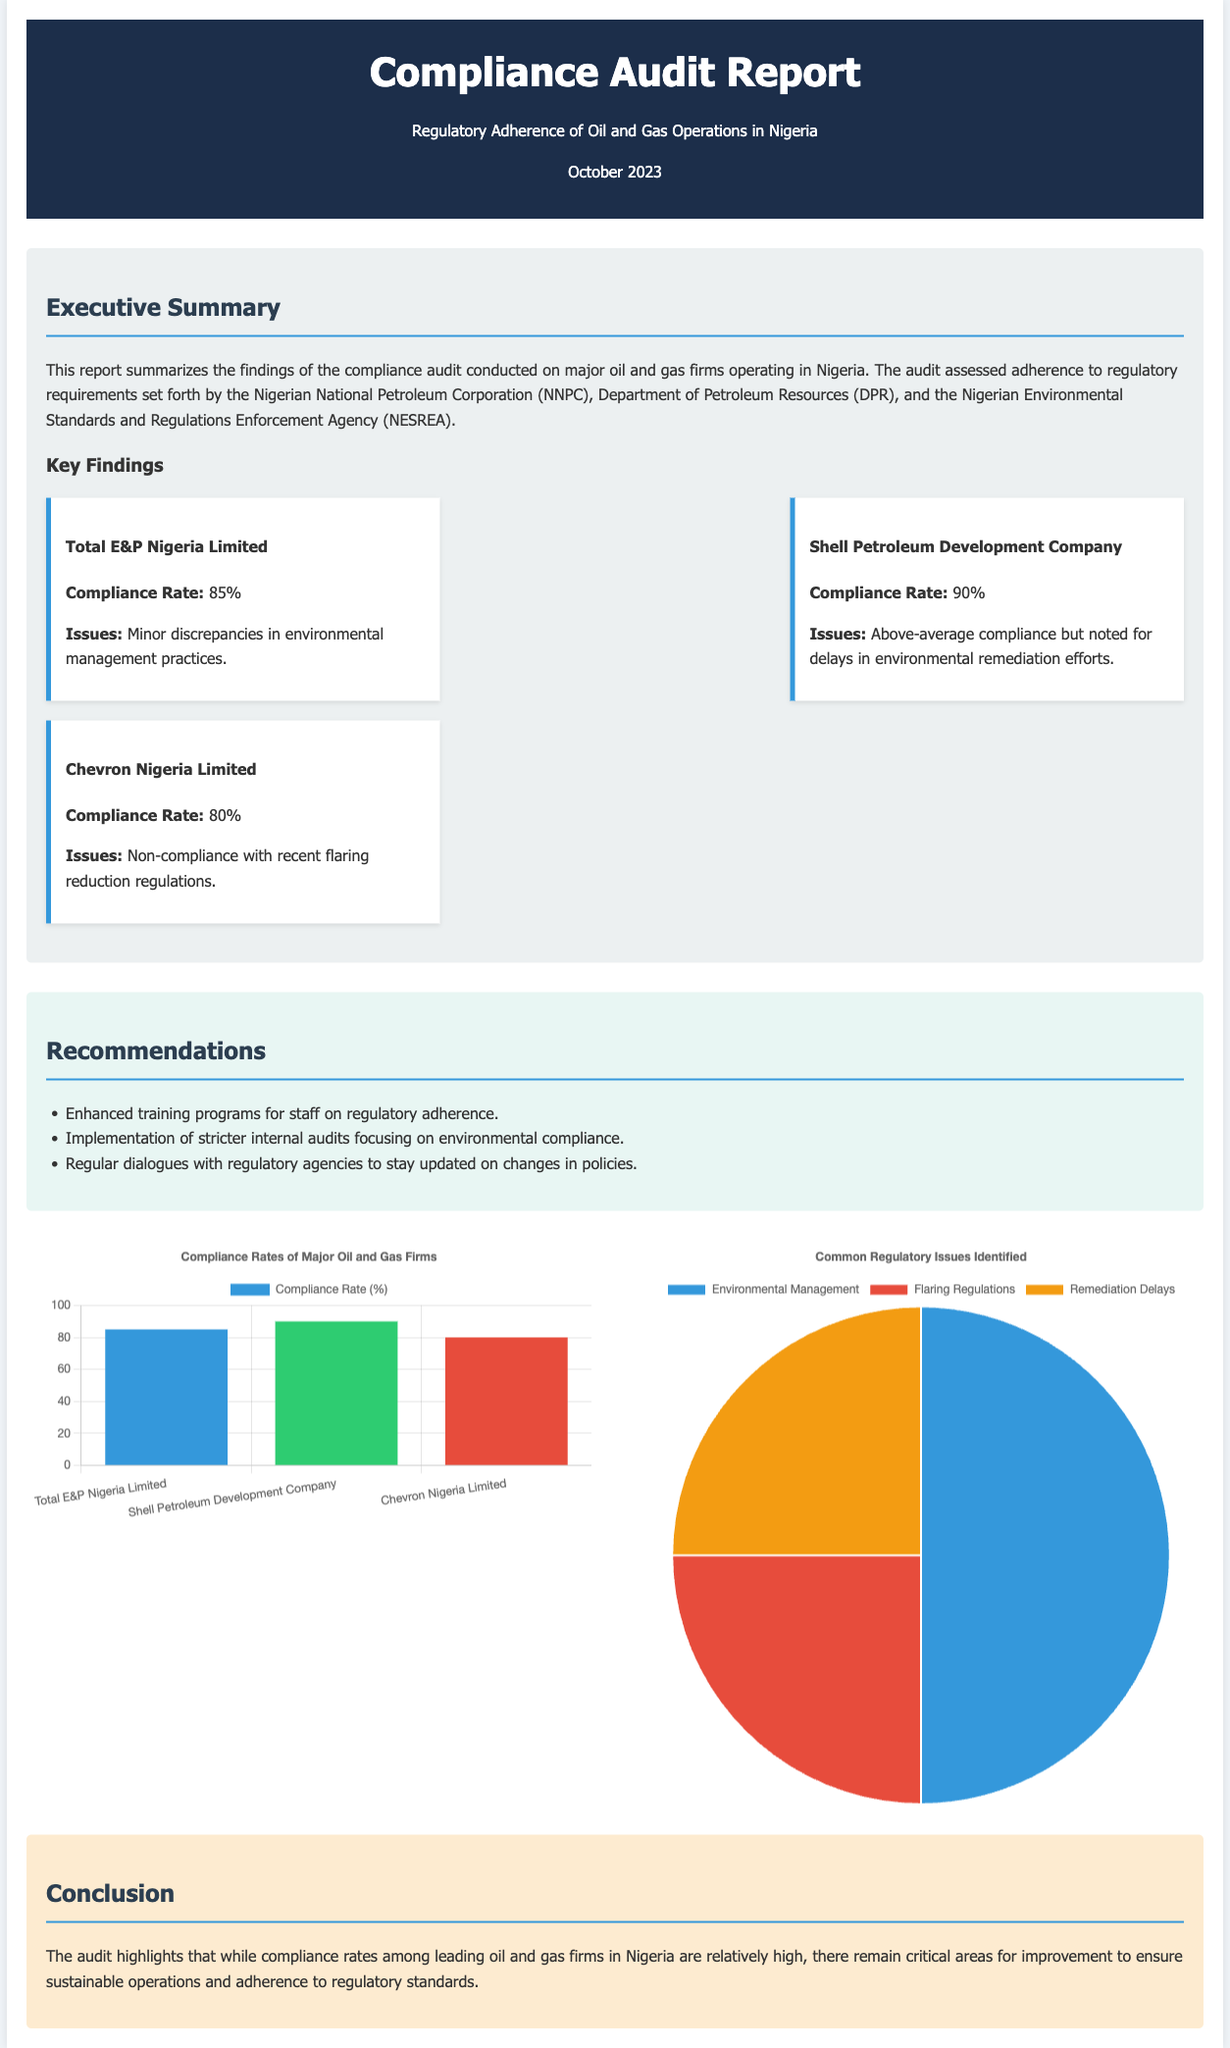What is the compliance rate for Total E&P Nigeria Limited? The compliance rate is stated under the key findings section for Total E&P Nigeria Limited.
Answer: 85% What regulatory body is referenced for compliance standards? The report mentions several regulatory bodies, including NNPC, DPR, and NESREA that set the compliance standards.
Answer: NNPC What are the common regulatory issues identified? The pie chart outlines the specific regulatory issues, detailing the count for each issue.
Answer: Environmental Management, Flaring Regulations, Remediation Delays Which company had the highest compliance rate? Based on the compliance rates displayed in the bar chart, one can identify which company had the highest compliance rate.
Answer: Shell Petroleum Development Company What recommendation focuses on internal processes? The recommendations section emphasizes enhancing internal audits as part of the compliance strategy.
Answer: Stricter internal audits What is the publication date of the report? The publication date is indicated toward the top of the document, right after the title.
Answer: October 2023 How many identified issues are related to flaring regulations? The pie chart displays specific counts for each regulatory issue, including those related to flaring regulations.
Answer: 1 